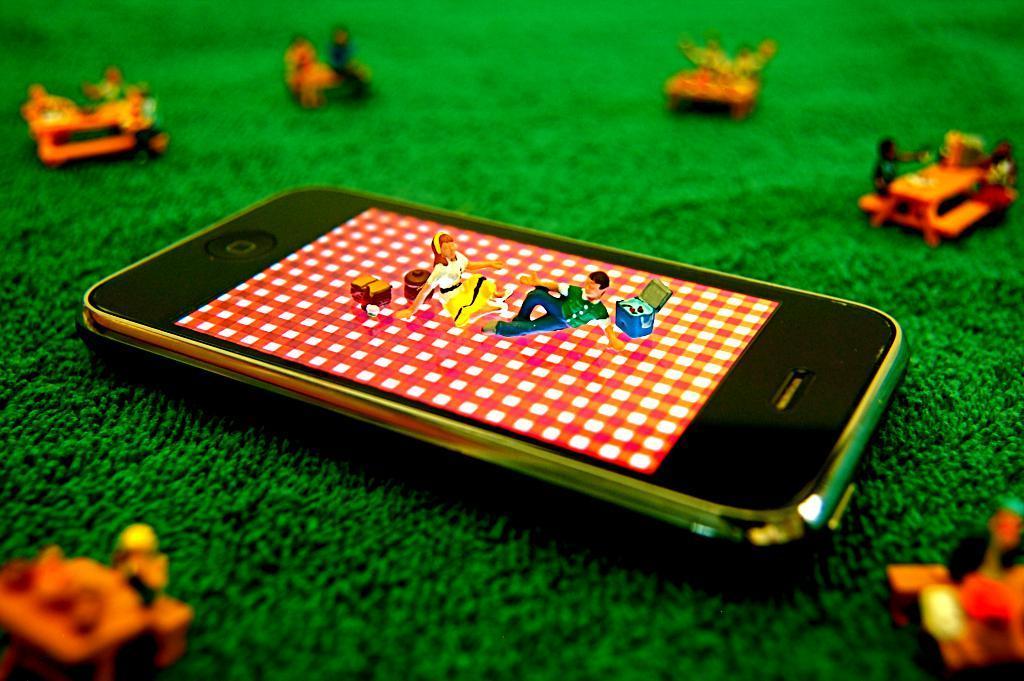Describe this image in one or two sentences. In this image in the center there is a mobile phone and there are toys. 